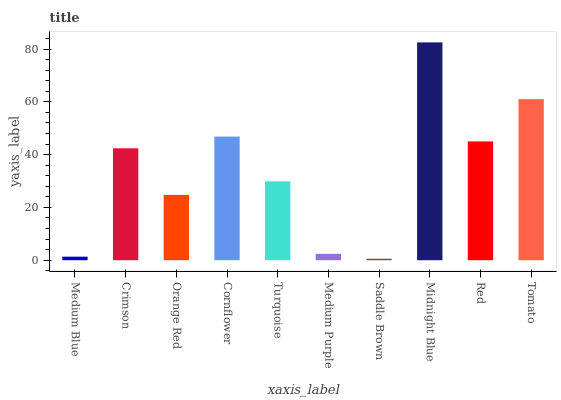Is Saddle Brown the minimum?
Answer yes or no. Yes. Is Midnight Blue the maximum?
Answer yes or no. Yes. Is Crimson the minimum?
Answer yes or no. No. Is Crimson the maximum?
Answer yes or no. No. Is Crimson greater than Medium Blue?
Answer yes or no. Yes. Is Medium Blue less than Crimson?
Answer yes or no. Yes. Is Medium Blue greater than Crimson?
Answer yes or no. No. Is Crimson less than Medium Blue?
Answer yes or no. No. Is Crimson the high median?
Answer yes or no. Yes. Is Turquoise the low median?
Answer yes or no. Yes. Is Medium Purple the high median?
Answer yes or no. No. Is Cornflower the low median?
Answer yes or no. No. 